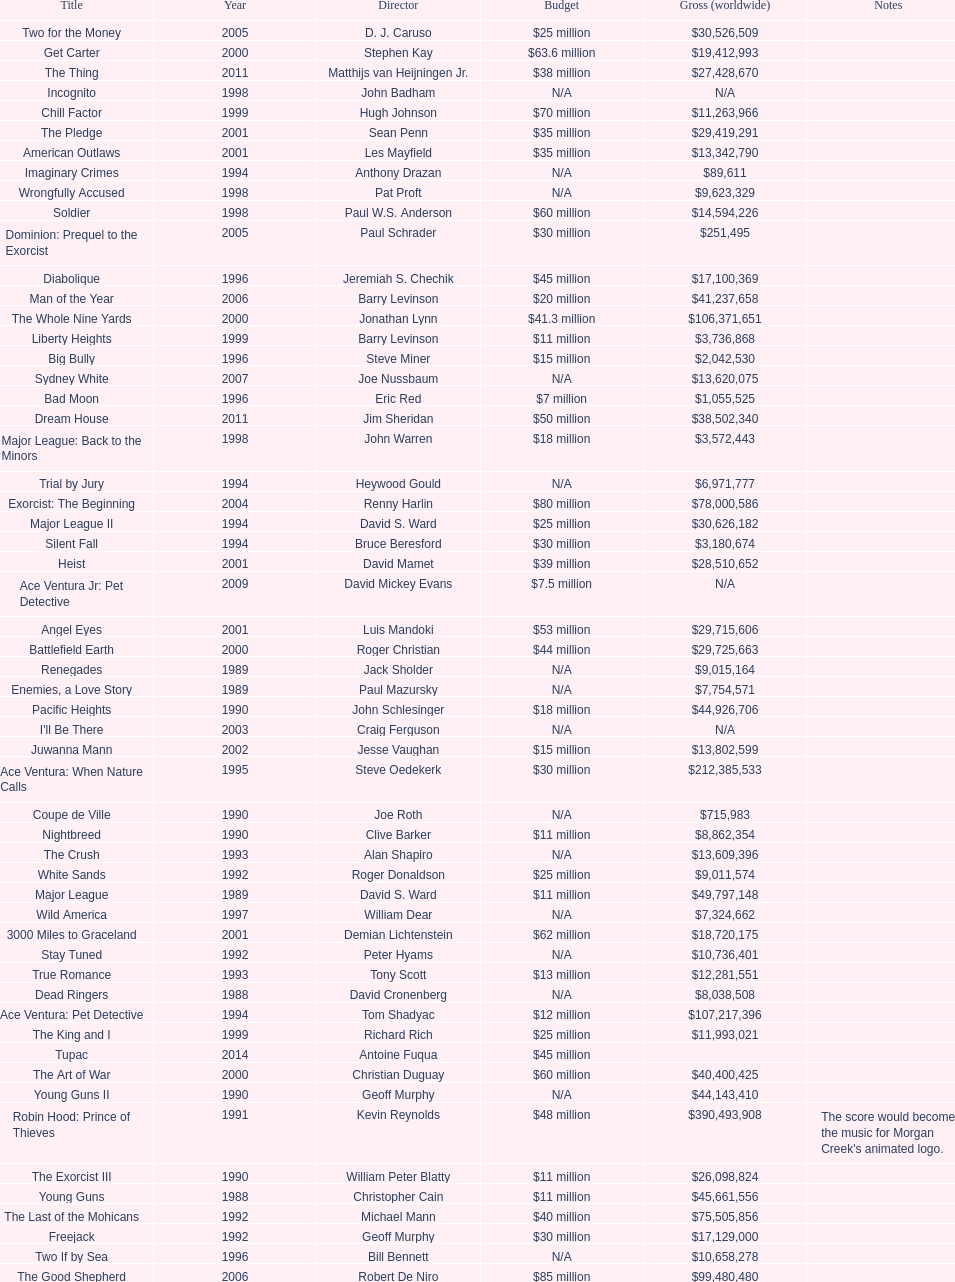Which morgan creek film grossed the most money prior to 1994? Robin Hood: Prince of Thieves. 